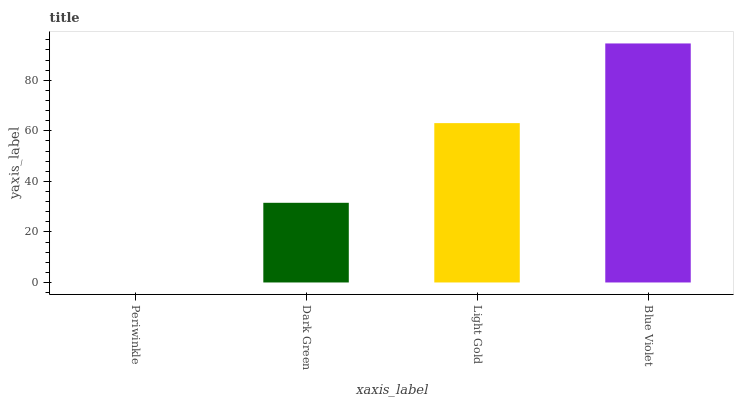Is Dark Green the minimum?
Answer yes or no. No. Is Dark Green the maximum?
Answer yes or no. No. Is Dark Green greater than Periwinkle?
Answer yes or no. Yes. Is Periwinkle less than Dark Green?
Answer yes or no. Yes. Is Periwinkle greater than Dark Green?
Answer yes or no. No. Is Dark Green less than Periwinkle?
Answer yes or no. No. Is Light Gold the high median?
Answer yes or no. Yes. Is Dark Green the low median?
Answer yes or no. Yes. Is Blue Violet the high median?
Answer yes or no. No. Is Blue Violet the low median?
Answer yes or no. No. 